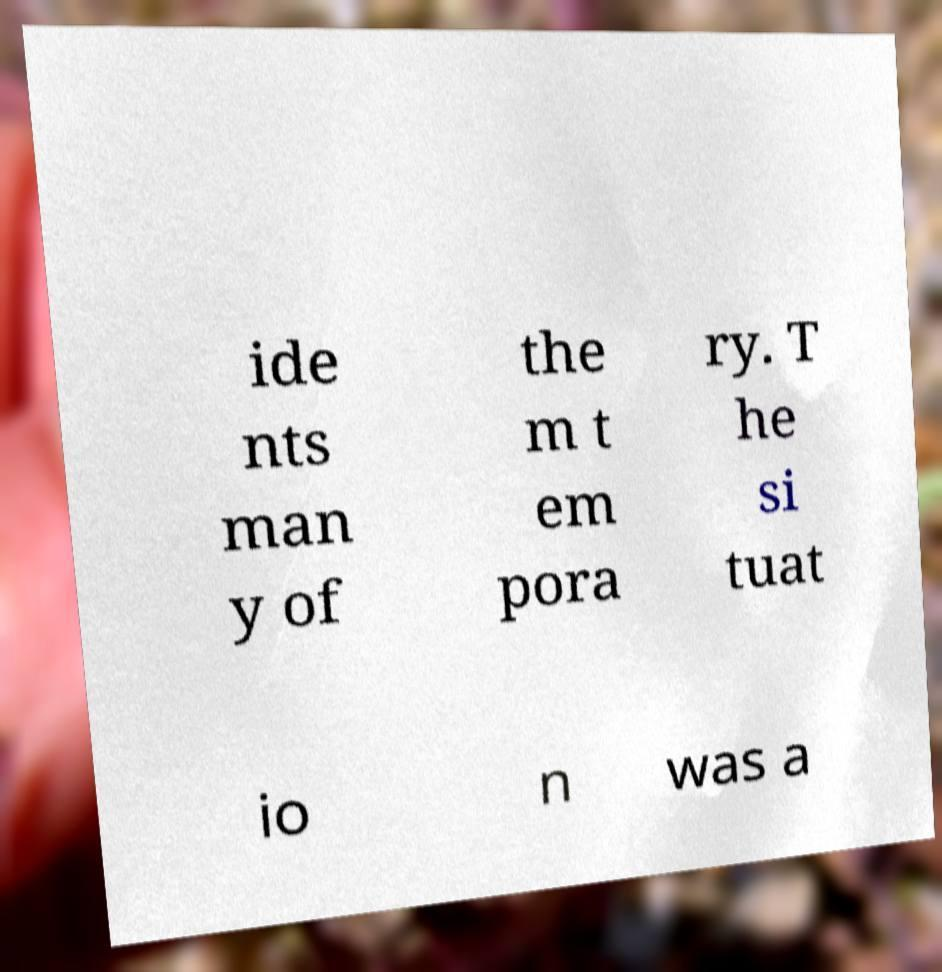Can you read and provide the text displayed in the image?This photo seems to have some interesting text. Can you extract and type it out for me? ide nts man y of the m t em pora ry. T he si tuat io n was a 